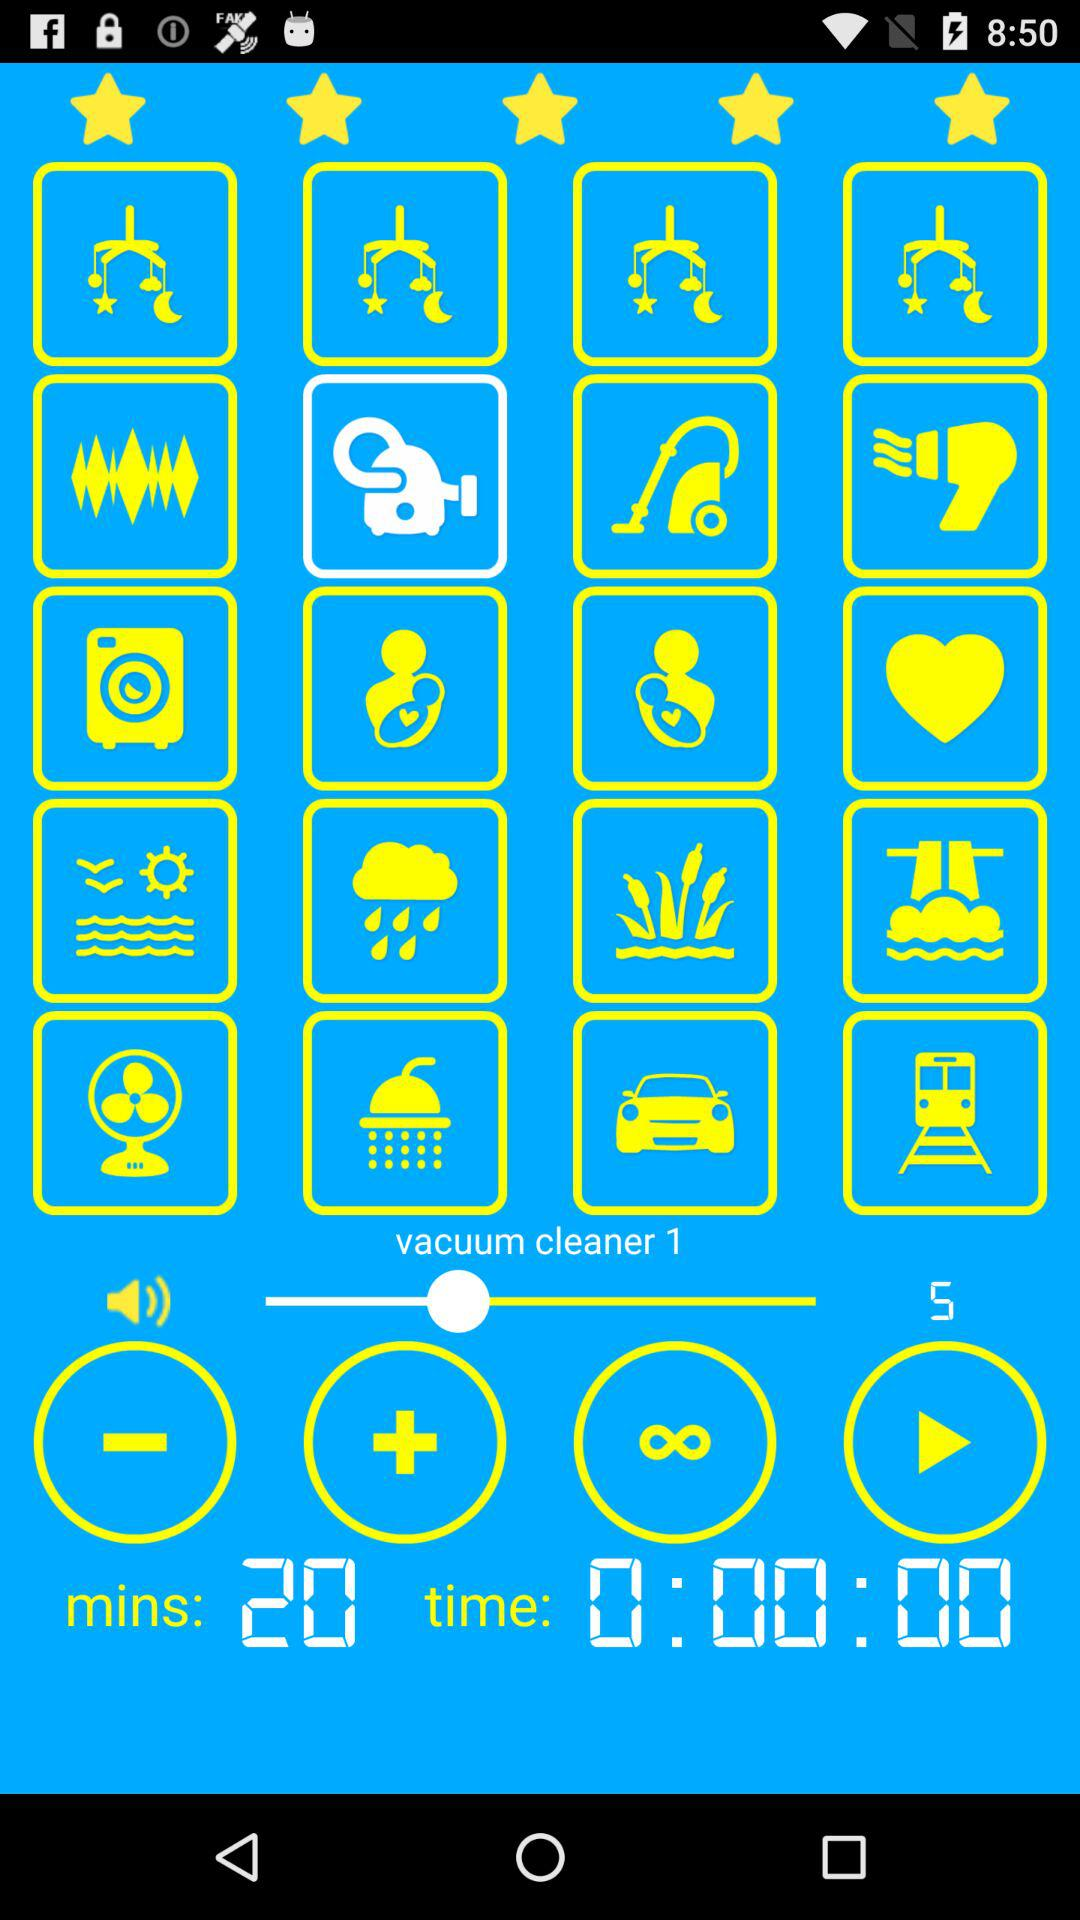What's the volume level? The volume level is 5. 